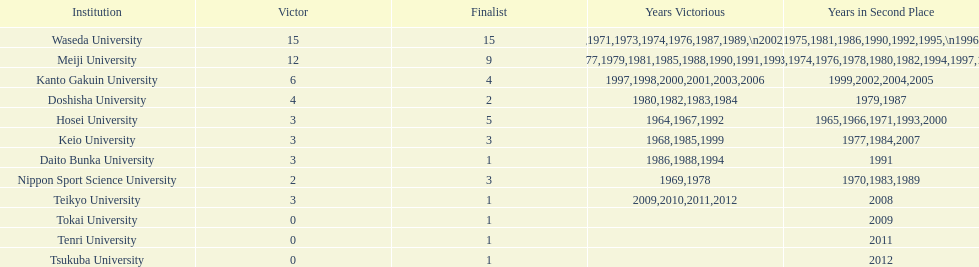How many championships does nippon sport science university have 2. 